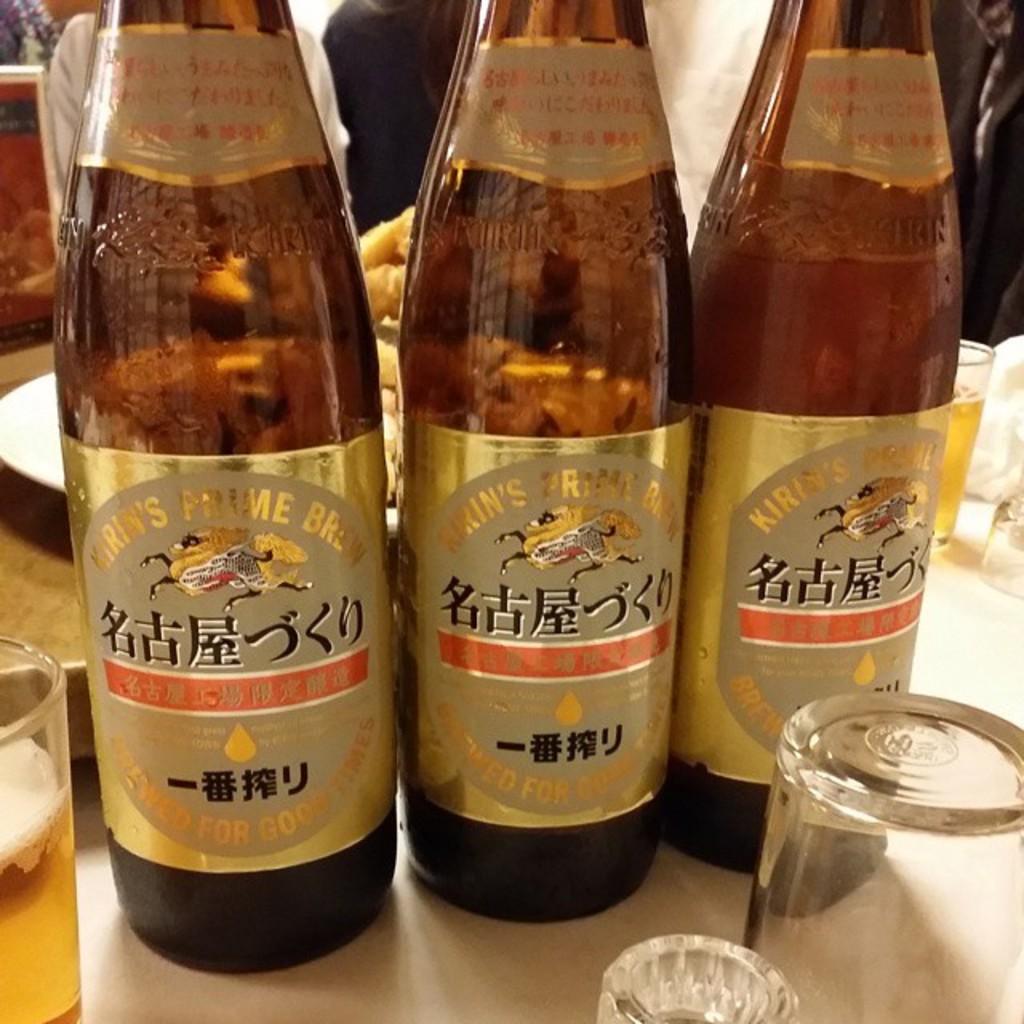What is the name on this bottle?
Provide a succinct answer. Kirin's prime brew. 